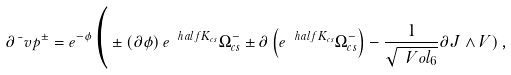Convert formula to latex. <formula><loc_0><loc_0><loc_500><loc_500>\partial \bar { \ } v p ^ { \pm } = e ^ { - \phi } \Big ( \pm \left ( \partial \phi \right ) e ^ { \ h a l f K _ { c s } } \Omega _ { c s } ^ { - } \pm \partial \left ( e ^ { \ h a l f K _ { c s } } \Omega _ { c s } ^ { - } \right ) - \frac { 1 } { \sqrt { \ V o l _ { 6 } } } \partial J \wedge V ) \, ,</formula> 